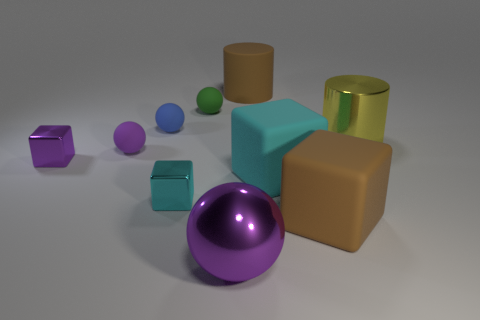The metal cylinder has what size?
Ensure brevity in your answer.  Large. How many things are either cyan rubber blocks or matte cylinders?
Keep it short and to the point. 2. There is a sphere that is the same material as the yellow thing; what is its color?
Ensure brevity in your answer.  Purple. Is the shape of the large shiny thing that is left of the big yellow cylinder the same as  the tiny purple rubber object?
Keep it short and to the point. Yes. How many objects are balls in front of the tiny green thing or matte cylinders behind the blue rubber object?
Offer a very short reply. 4. There is another big metal object that is the same shape as the green object; what is its color?
Your answer should be compact. Purple. Do the small cyan object and the purple shiny thing that is on the left side of the big purple metallic sphere have the same shape?
Give a very brief answer. Yes. What material is the big brown cylinder?
Provide a succinct answer. Rubber. What is the size of the purple shiny thing that is the same shape as the small purple matte thing?
Your response must be concise. Large. What number of other things are the same material as the large brown cylinder?
Your answer should be very brief. 5. 